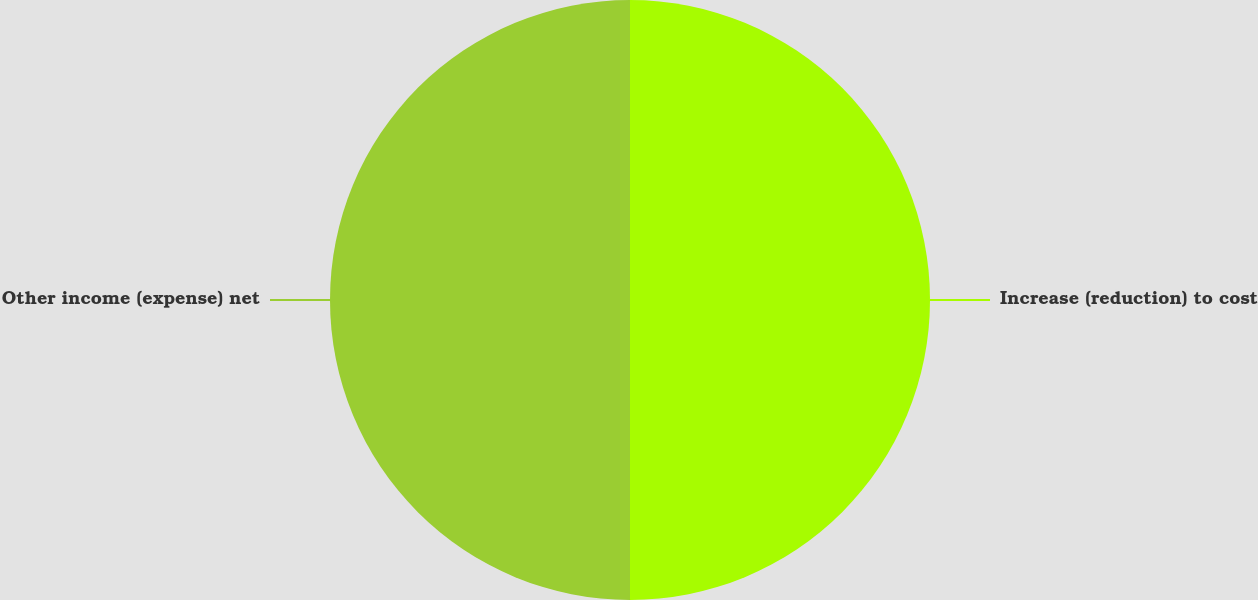<chart> <loc_0><loc_0><loc_500><loc_500><pie_chart><fcel>Increase (reduction) to cost<fcel>Other income (expense) net<nl><fcel>50.0%<fcel>50.0%<nl></chart> 